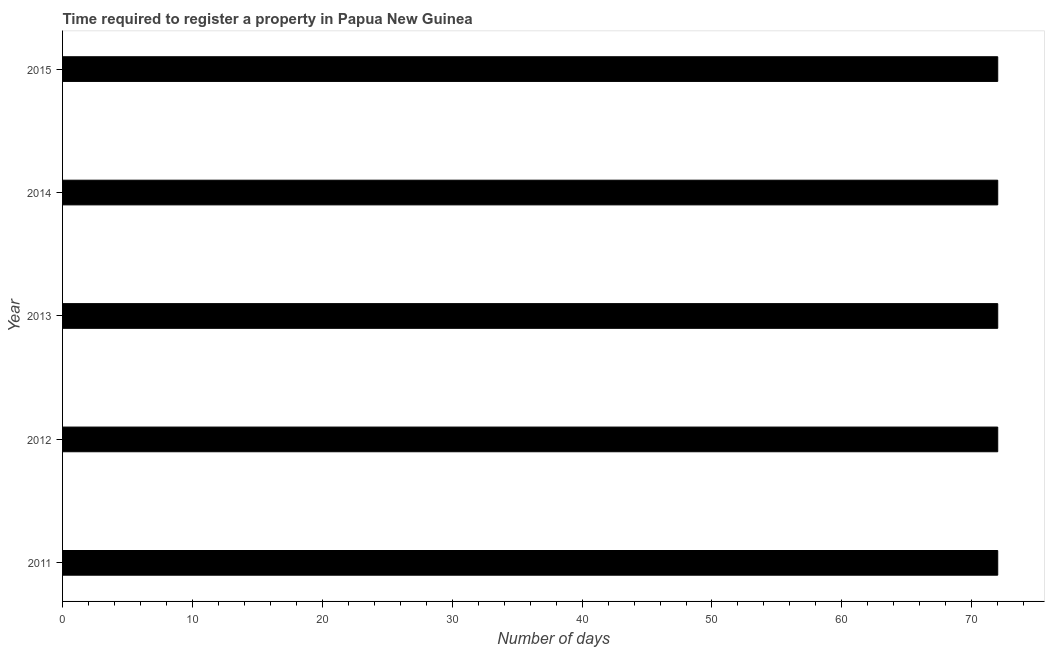Does the graph contain any zero values?
Give a very brief answer. No. What is the title of the graph?
Your response must be concise. Time required to register a property in Papua New Guinea. What is the label or title of the X-axis?
Make the answer very short. Number of days. What is the number of days required to register property in 2011?
Make the answer very short. 72. Across all years, what is the maximum number of days required to register property?
Make the answer very short. 72. Across all years, what is the minimum number of days required to register property?
Provide a succinct answer. 72. In which year was the number of days required to register property minimum?
Give a very brief answer. 2011. What is the sum of the number of days required to register property?
Provide a short and direct response. 360. What is the difference between the number of days required to register property in 2011 and 2012?
Your response must be concise. 0. What is the average number of days required to register property per year?
Give a very brief answer. 72. What is the median number of days required to register property?
Keep it short and to the point. 72. In how many years, is the number of days required to register property greater than 38 days?
Provide a short and direct response. 5. Do a majority of the years between 2013 and 2012 (inclusive) have number of days required to register property greater than 24 days?
Keep it short and to the point. No. What is the ratio of the number of days required to register property in 2013 to that in 2015?
Make the answer very short. 1. What is the difference between the highest and the second highest number of days required to register property?
Provide a short and direct response. 0. Is the sum of the number of days required to register property in 2011 and 2015 greater than the maximum number of days required to register property across all years?
Your answer should be compact. Yes. What is the difference between the highest and the lowest number of days required to register property?
Ensure brevity in your answer.  0. How many bars are there?
Keep it short and to the point. 5. What is the Number of days of 2011?
Your answer should be very brief. 72. What is the Number of days in 2012?
Your response must be concise. 72. What is the Number of days in 2013?
Keep it short and to the point. 72. What is the Number of days in 2014?
Make the answer very short. 72. What is the Number of days in 2015?
Make the answer very short. 72. What is the difference between the Number of days in 2011 and 2012?
Your response must be concise. 0. What is the difference between the Number of days in 2011 and 2013?
Give a very brief answer. 0. What is the difference between the Number of days in 2011 and 2015?
Provide a succinct answer. 0. What is the difference between the Number of days in 2012 and 2015?
Your answer should be very brief. 0. What is the difference between the Number of days in 2013 and 2014?
Give a very brief answer. 0. What is the difference between the Number of days in 2013 and 2015?
Your response must be concise. 0. What is the ratio of the Number of days in 2011 to that in 2014?
Make the answer very short. 1. What is the ratio of the Number of days in 2013 to that in 2014?
Offer a very short reply. 1. What is the ratio of the Number of days in 2014 to that in 2015?
Keep it short and to the point. 1. 